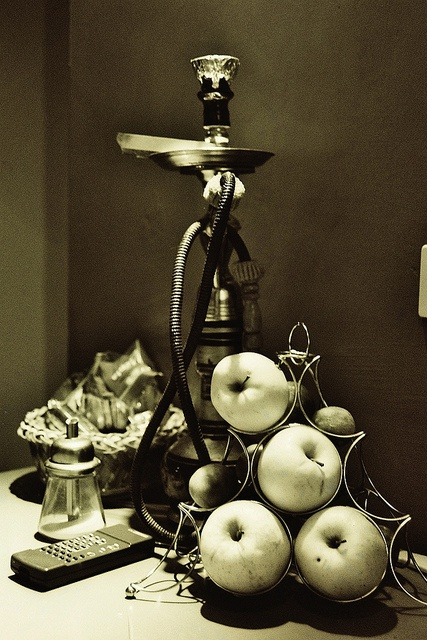Describe the objects in this image and their specific colors. I can see apple in black, beige, tan, khaki, and olive tones, apple in black, khaki, tan, and olive tones, apple in black, olive, khaki, and beige tones, remote in black, tan, khaki, and beige tones, and apple in black, tan, khaki, and beige tones in this image. 